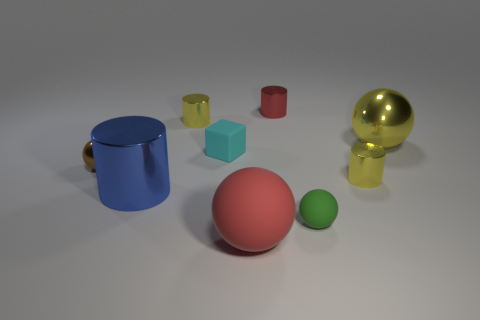Subtract all tiny red shiny cylinders. How many cylinders are left? 3 Subtract all yellow blocks. How many yellow cylinders are left? 2 Subtract all red cylinders. How many cylinders are left? 3 Subtract 2 balls. How many balls are left? 2 Add 1 large blue metal things. How many objects exist? 10 Subtract all cylinders. How many objects are left? 5 Subtract all brown cylinders. Subtract all blue spheres. How many cylinders are left? 4 Subtract all small green balls. Subtract all cyan matte objects. How many objects are left? 7 Add 8 blue things. How many blue things are left? 9 Add 8 large gray cylinders. How many large gray cylinders exist? 8 